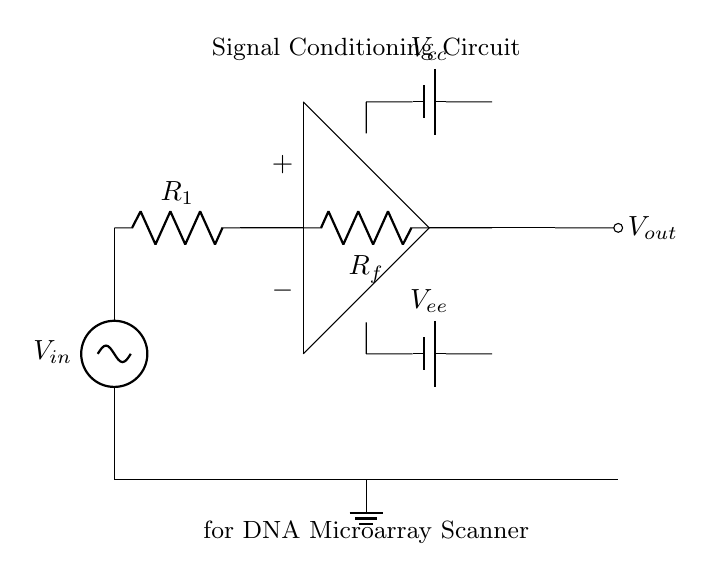What type of circuit is shown? The circuit is a signal conditioning circuit, specifically designed to condition signals for a DNA microarray scanner. The functionality and components used, including the operational amplifier, indicate its role in signal processing.
Answer: signal conditioning circuit What is the function of the operational amplifier? The operational amplifier amplifies the difference in voltage between its two input terminals, providing gain to the input signal. This is crucial in signal conditioning as it enhances the signal to make it suitable for analysis.
Answer: amplification What components are used in the feedback loop? The feedback loop consists of a resistor labeled as Rf connected between the output and the inverting input of the operational amplifier. This configuration allows for stability and control of the gain in the circuit.
Answer: Resistor Rf What voltages are provided by the power supply? The circuit includes two power supply voltages: Vcc and Vee. These provide the necessary power for the operational amplifier to function correctly. Vcc is typically positive and Vee negative.
Answer: Vcc and Vee What is the purpose of the resistor labeled R1? Resistor R1 limits the input current to the operational amplifier and helps define the input impedance of the circuit, which is important for preventing loading effects on the circuit being measured.
Answer: current limiting How does the circuit ensure proper grounding? The circuit ensures proper grounding by connecting the ground node at the bottom to the negative side of the power supplies and providing a reference level for the voltage measurements and signal processing.
Answer: grounding What output signal is expected from this circuit? The output signal, Vout, is expected to be an amplified version of the input signal Vin after processing through the operational amplifier, which enhances its characteristics necessary for further analysis.
Answer: amplified signal 